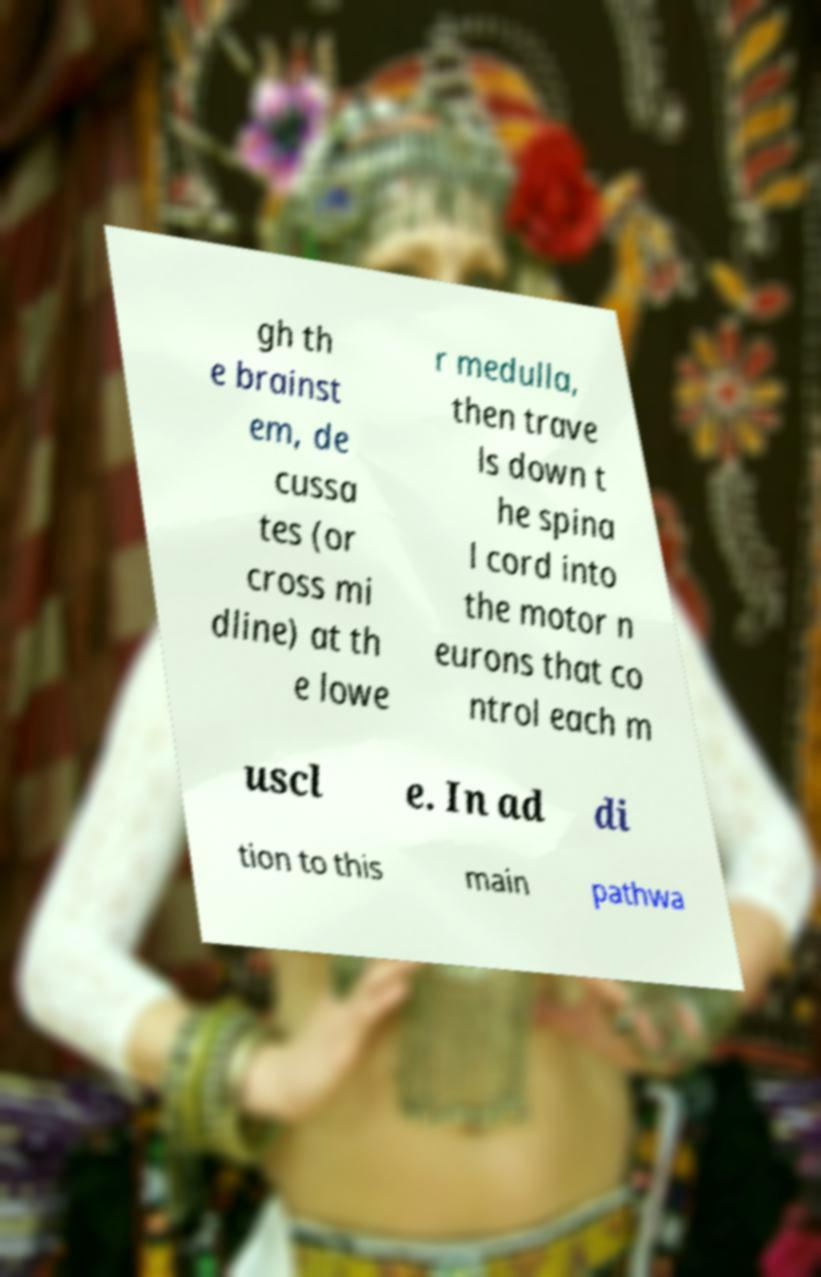What messages or text are displayed in this image? I need them in a readable, typed format. gh th e brainst em, de cussa tes (or cross mi dline) at th e lowe r medulla, then trave ls down t he spina l cord into the motor n eurons that co ntrol each m uscl e. In ad di tion to this main pathwa 